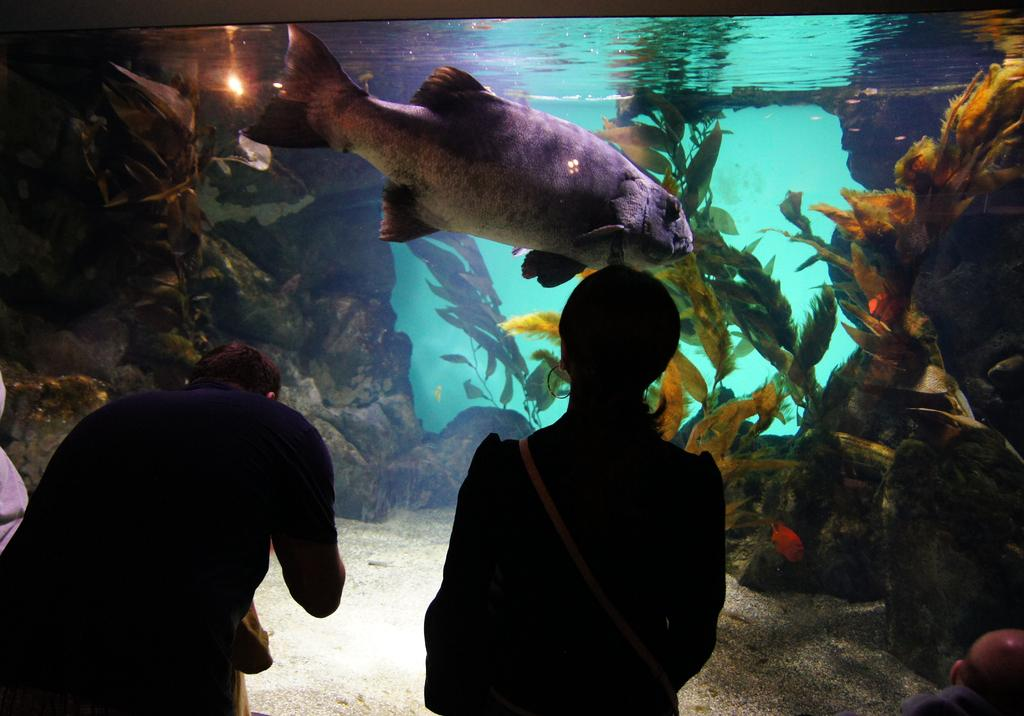Who are the two people standing in front of in the image? The two people are standing in front of an aquarium. What can be seen inside the aquarium? There are fish, plants, rocks, and water inside the aquarium. What type of environment is depicted in the image? The image shows an underwater environment with fish, plants, and rocks. What color is the yoke that the fish are pulling in the image? There is no yoke or any indication of a yoke being pulled by fish in the image. 